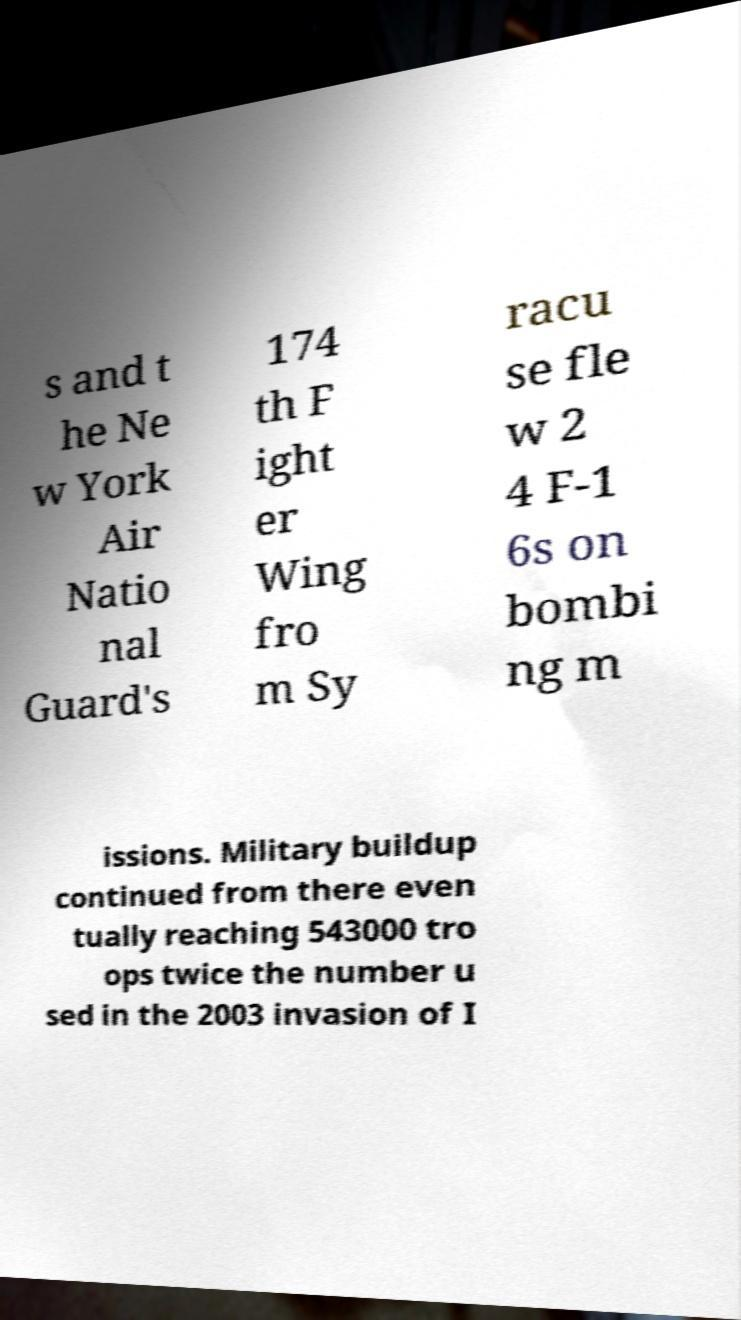There's text embedded in this image that I need extracted. Can you transcribe it verbatim? s and t he Ne w York Air Natio nal Guard's 174 th F ight er Wing fro m Sy racu se fle w 2 4 F-1 6s on bombi ng m issions. Military buildup continued from there even tually reaching 543000 tro ops twice the number u sed in the 2003 invasion of I 